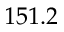<formula> <loc_0><loc_0><loc_500><loc_500>1 5 1 . 2</formula> 